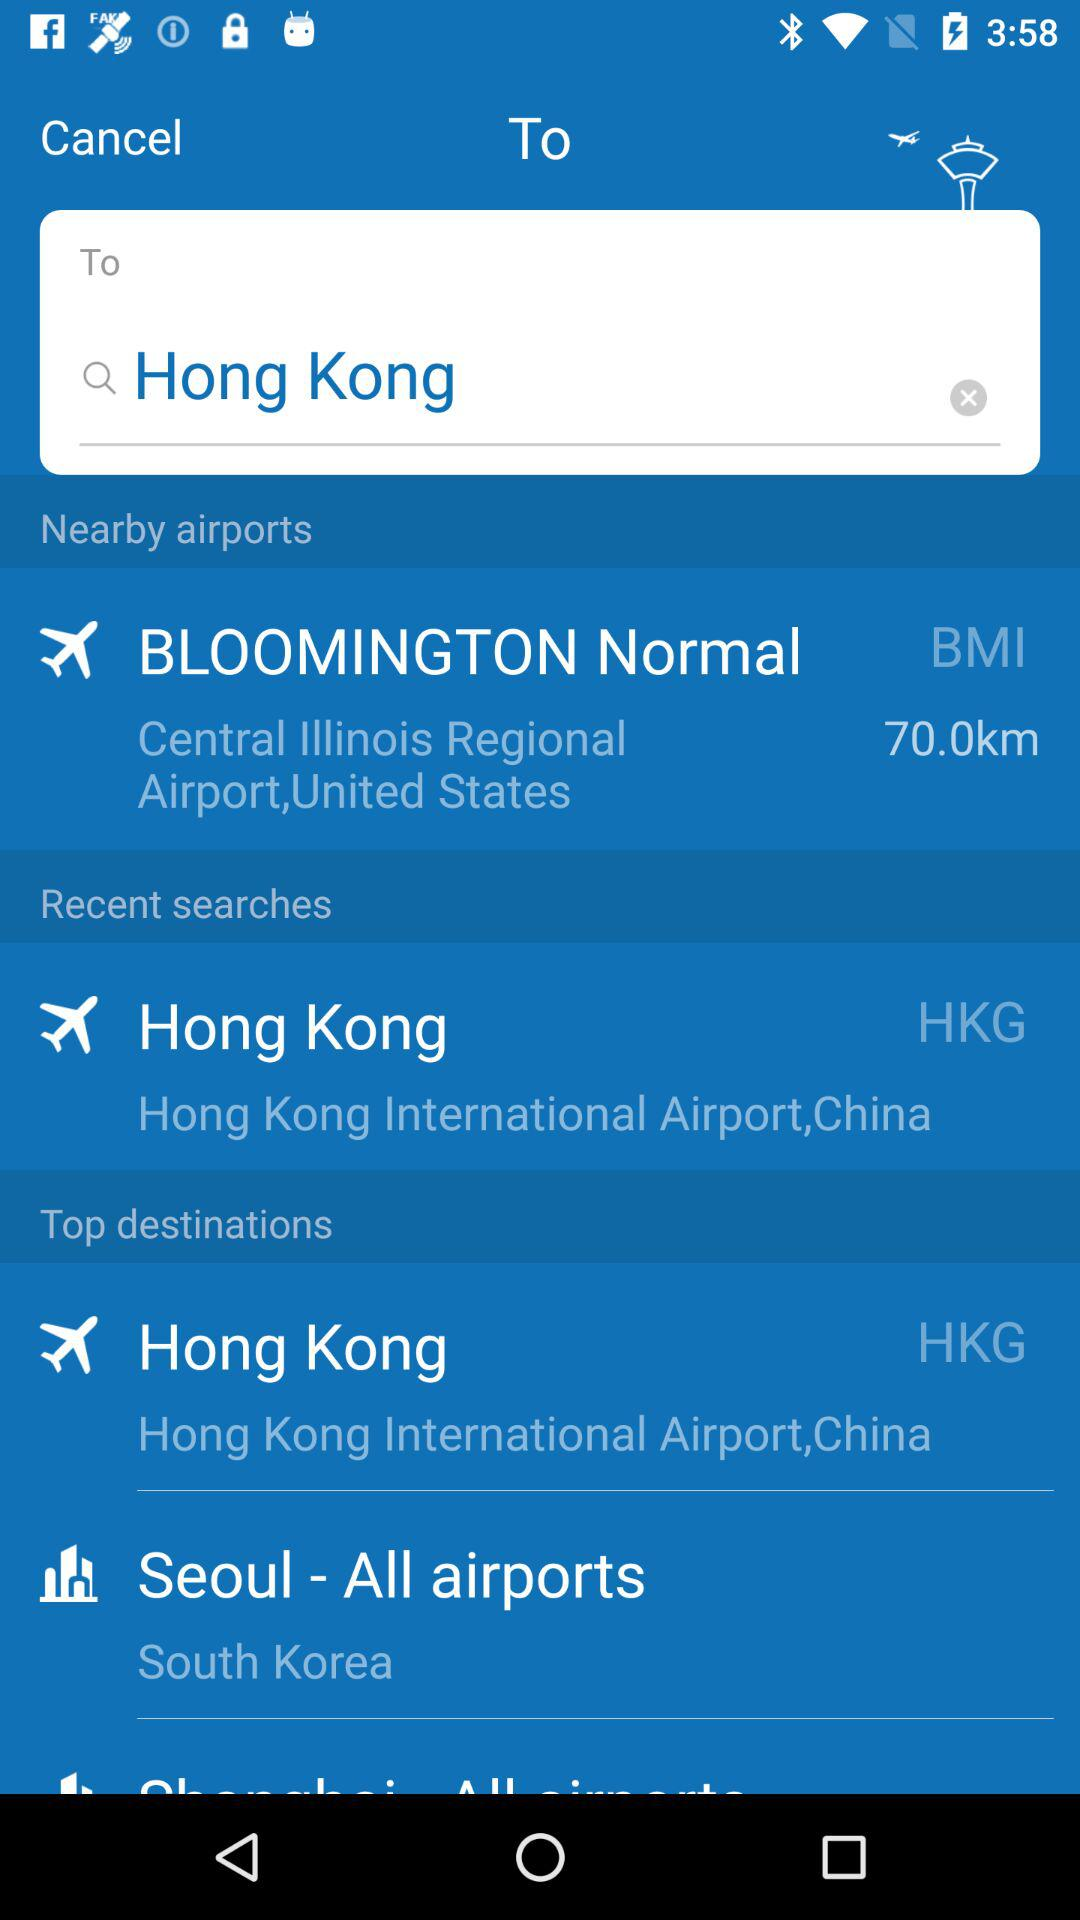What are the top destinations shown on the screen? The top destinations are Hong Kong International Airport, China and South Korea. 